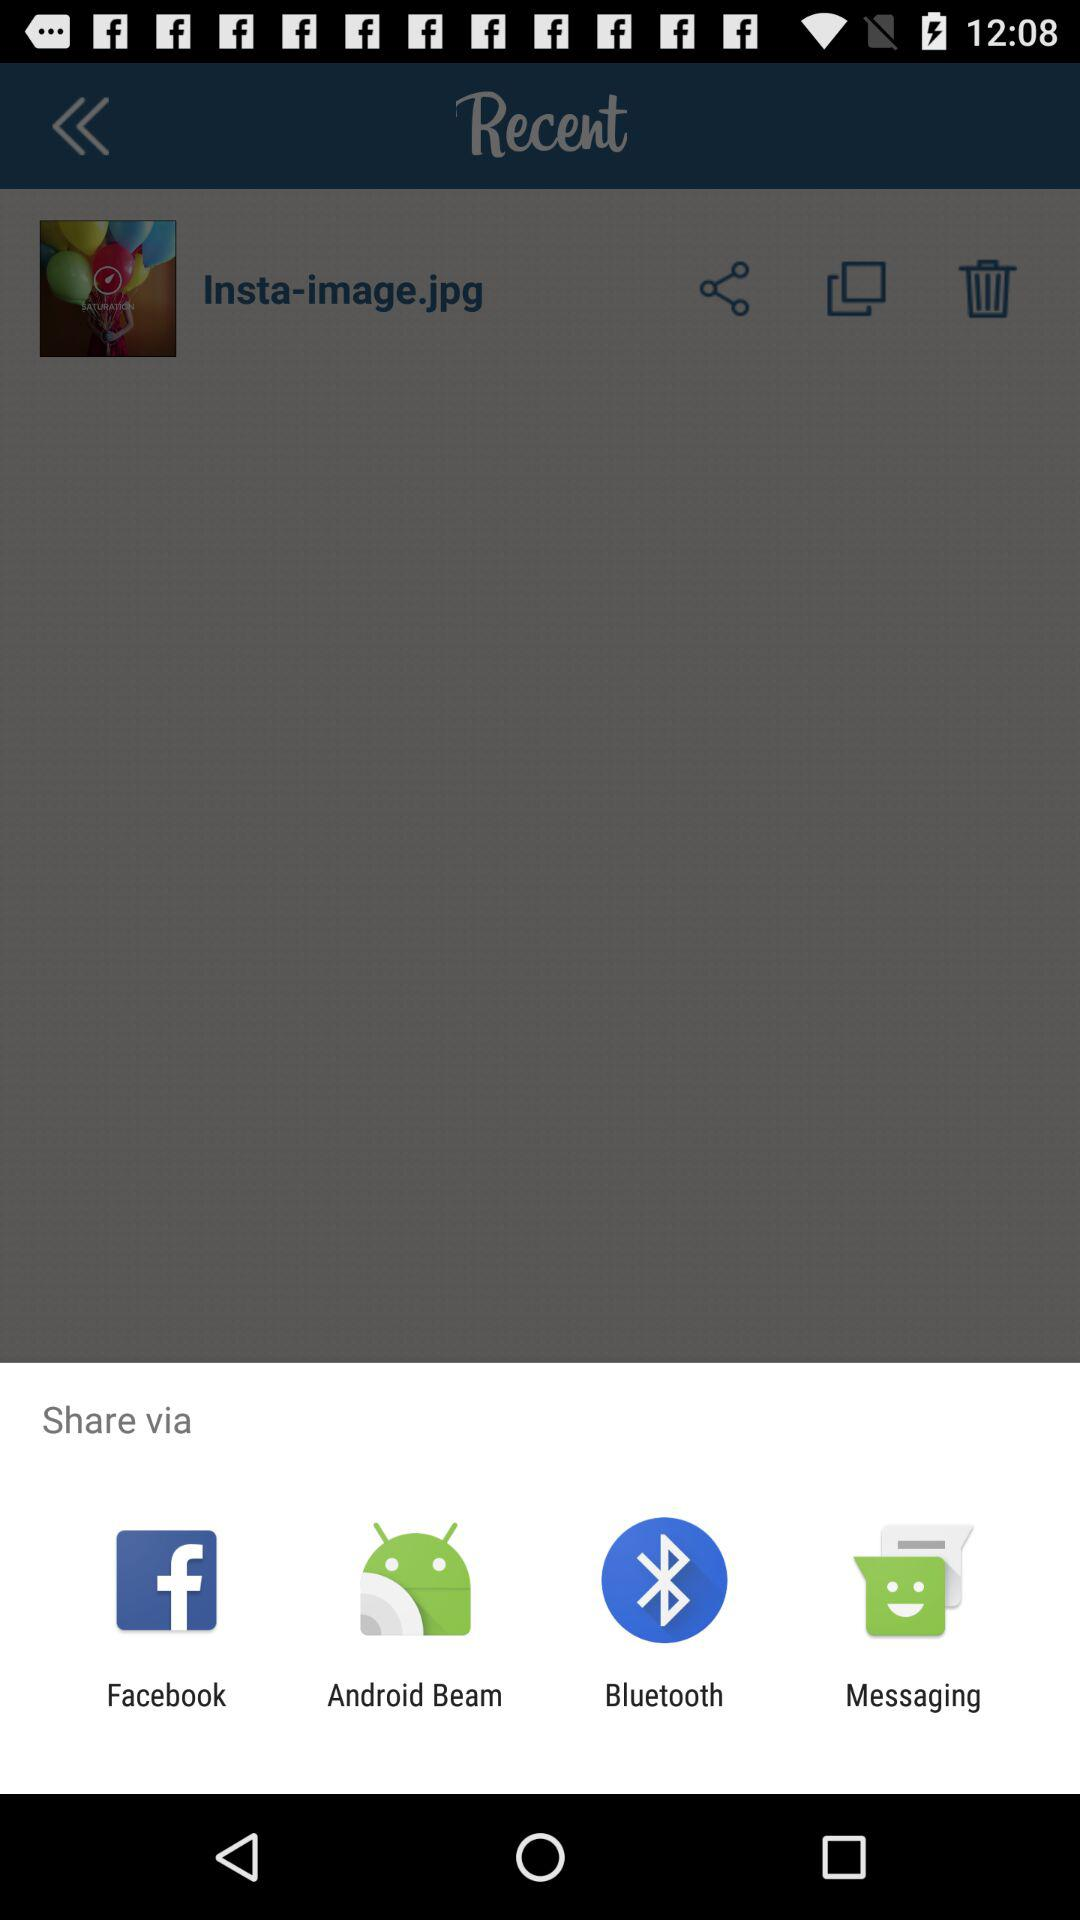What are the available sharing options? The available sharing options are "Facebook", "Android Beam", "Bluetooth" and "Messaging". 